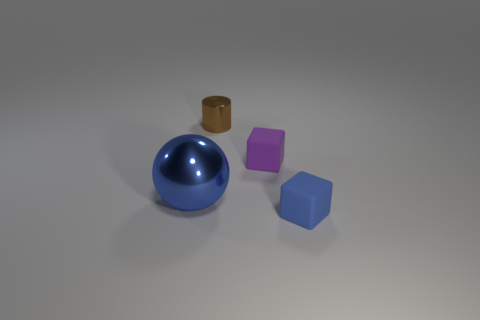Are there any tiny green metallic blocks? There are no tiny green metallic blocks in the image. We only see one shiny blue sphere and two cubes, one violet and one blue, on a light surface. 